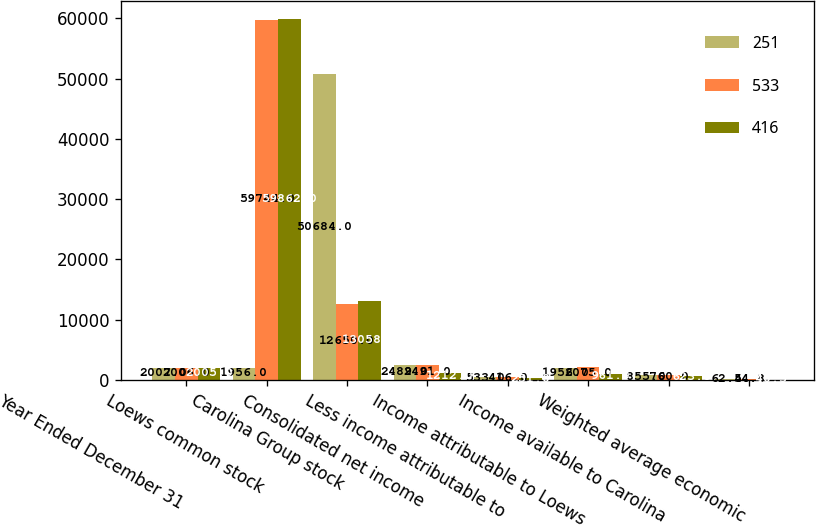Convert chart to OTSL. <chart><loc_0><loc_0><loc_500><loc_500><stacked_bar_chart><ecel><fcel>Year Ended December 31<fcel>Loews common stock<fcel>Carolina Group stock<fcel>Consolidated net income<fcel>Less income attributable to<fcel>Income attributable to Loews<fcel>Income available to Carolina<fcel>Weighted average economic<nl><fcel>251<fcel>2007<fcel>1956<fcel>50684<fcel>2489<fcel>533<fcel>1956<fcel>855<fcel>62.4<nl><fcel>533<fcel>2006<fcel>59744<fcel>12650<fcel>2491<fcel>416<fcel>2075<fcel>760<fcel>54.8<nl><fcel>416<fcel>2005<fcel>59862<fcel>13058<fcel>1212<fcel>251<fcel>961<fcel>623<fcel>40.3<nl></chart> 